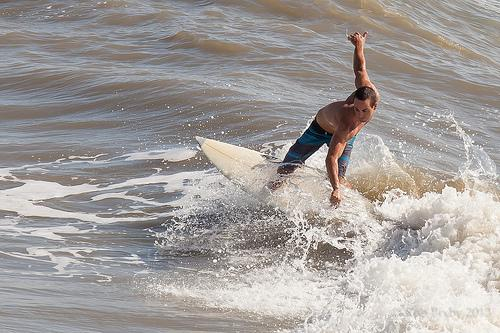Evaluate the quality of the photograph and specify any elements that contribute to its quality. The image is of medium quality, with some parts quite detailed like the hair and clothing, but the water and splashes look less detailed. Mention a distinctive feature of the man's clothing and provide a brief description of the scene. The man is wearing blue and black shorts, riding a white surfboard on brown ocean waters. Briefly explain how the person in the image is positioned and what they are doing. The person is bending over, twisting for balance and has arms straight out on the sides as they surf on ocean waves. How many unique colors can you identify being worn by the man in the image? There are two unique colors on the man's clothing: blue and black.  Analyze the possible interaction between the objects in the image. The man's movements and the force exerted on the surfboard create splashes and interaction with the water, changing the waves' forms. What is the primary object in the image and what action is it performing? The primary object is a man on a surfboard who is surfing on ocean waves. Consider any notable aspects of the surfer's physical appearance or their environment that stand out in the image. The surfer has dark hair, no shirt, and is wearing blue and black shorts. The surrounding water is rough with foam on the surface. Describe the overall sentiment or emotion conveyed by the image. The image conveys excitement, adventure, and a sense of freedom as the man surfs the ocean waves. Identify any significant facial features of the person in the image and describe the water color. The person has brown hair, a close cut hairstyle and a nose in profile. The water appears to be a dirty grey-brown color. What type of wave conditions are visible in the image, and how are they portrayed by the ocean water? The wave conditions seem rough, portrayed by brownish water and some really nice, tall ocean waves splashing around the surfer. 